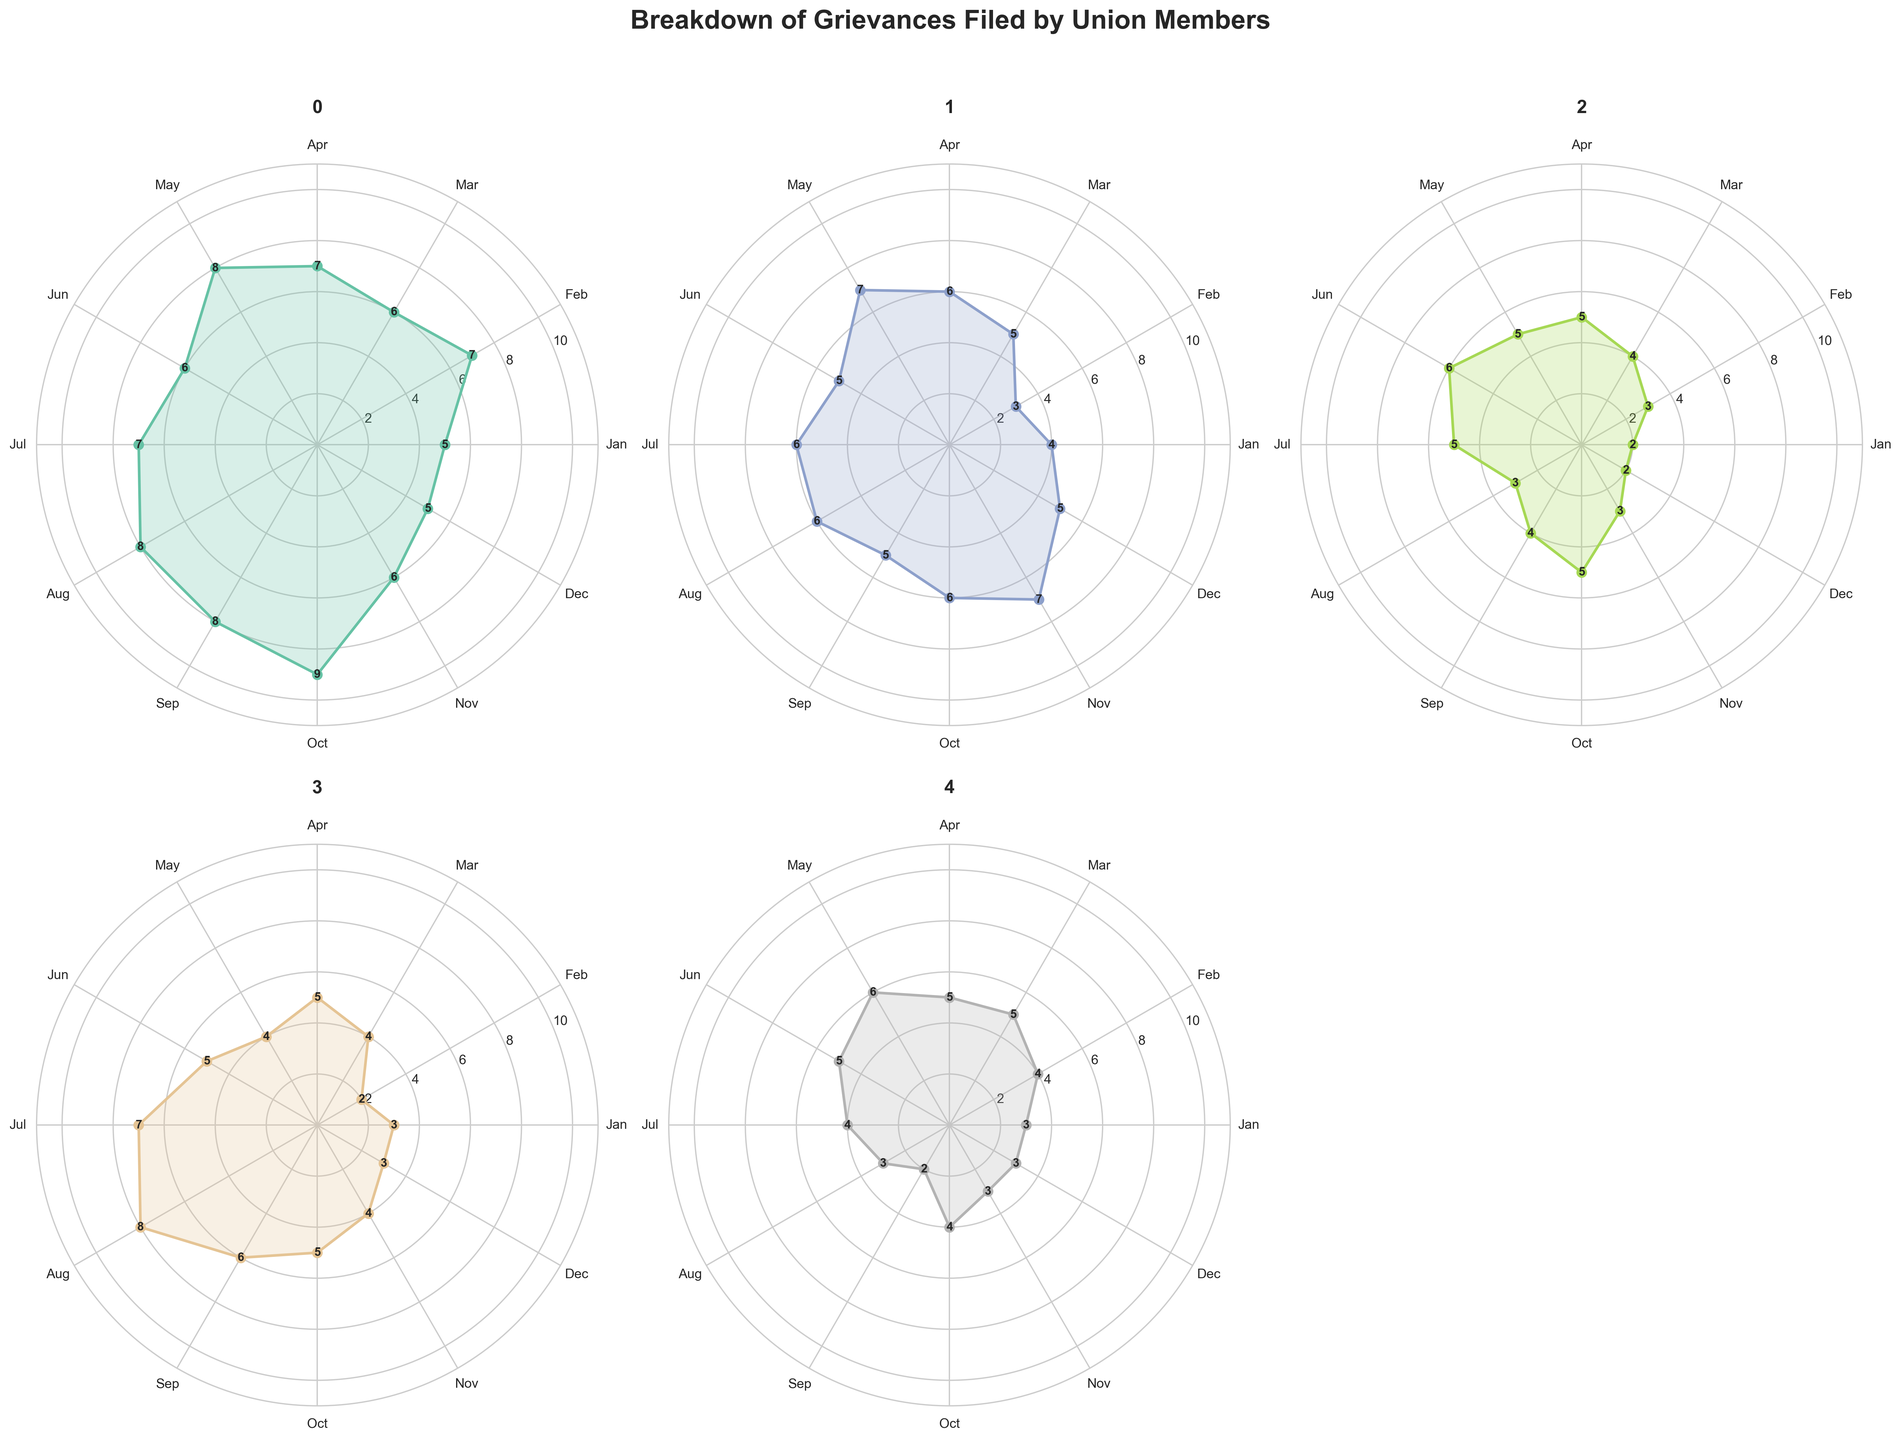How many types of issues are displayed in the figure? The figure's title and the number of subplots indicate the types of issues. Each subplot represents a different type of issue. There are five subplots in total.
Answer: Five What is the title of the figure? The title is displayed prominently at the top of the figure.
Answer: Breakdown of Grievances Filed by Union Members Which issue type had the most grievances filed in October? By looking at the values indicated for October in each subplot, we can compare the counts. Wage Disputes had the highest value.
Answer: Wage Disputes Which months had the highest number of grievances for Health and Safety issues? Reviewing the values for Health and Safety subplots, we see the highest is in July and August.
Answer: July and August What is the average number of Discrimination grievances filed in the first quarter (Jan, Feb, Mar)? Sum the values for January, February, and March, then divide by 3. (2+3+4)/3 = 3
Answer: 3 In which month did Wage Disputes reach their highest count, and what was the count? Examine the points on the Wage Disputes subplot and look for the highest value, marked by annotations. October has the highest count of 9.
Answer: October, 9 Compare the grievances of Harassment in January and June. Which month had more, and by how much? Find the values for January and June on the Harassment subplot, then subtract the smaller value from the larger one. January has 3, and June has 5, so June has 2 more.
Answer: June, 2 What is the total number of grievances for Working Conditions across the entire year? Sum the monthly values for Working Conditions (4+3+5+6+7+5+6+6+5+6+7+5).
Answer: 65 How did the number of grievances for Discrimination change from September to October? Look at the values for Discrimination in September and October. In September it is 4, and it goes up to 5 in October.
Answer: Increased by 1 Which issue showed the most significant monthly fluctuation throughout the year? Review the subplots and identify the issue with the highest range of monthly differences. Health and Safety shows a noticeable shift, especially around the mid-year.
Answer: Health and Safety 